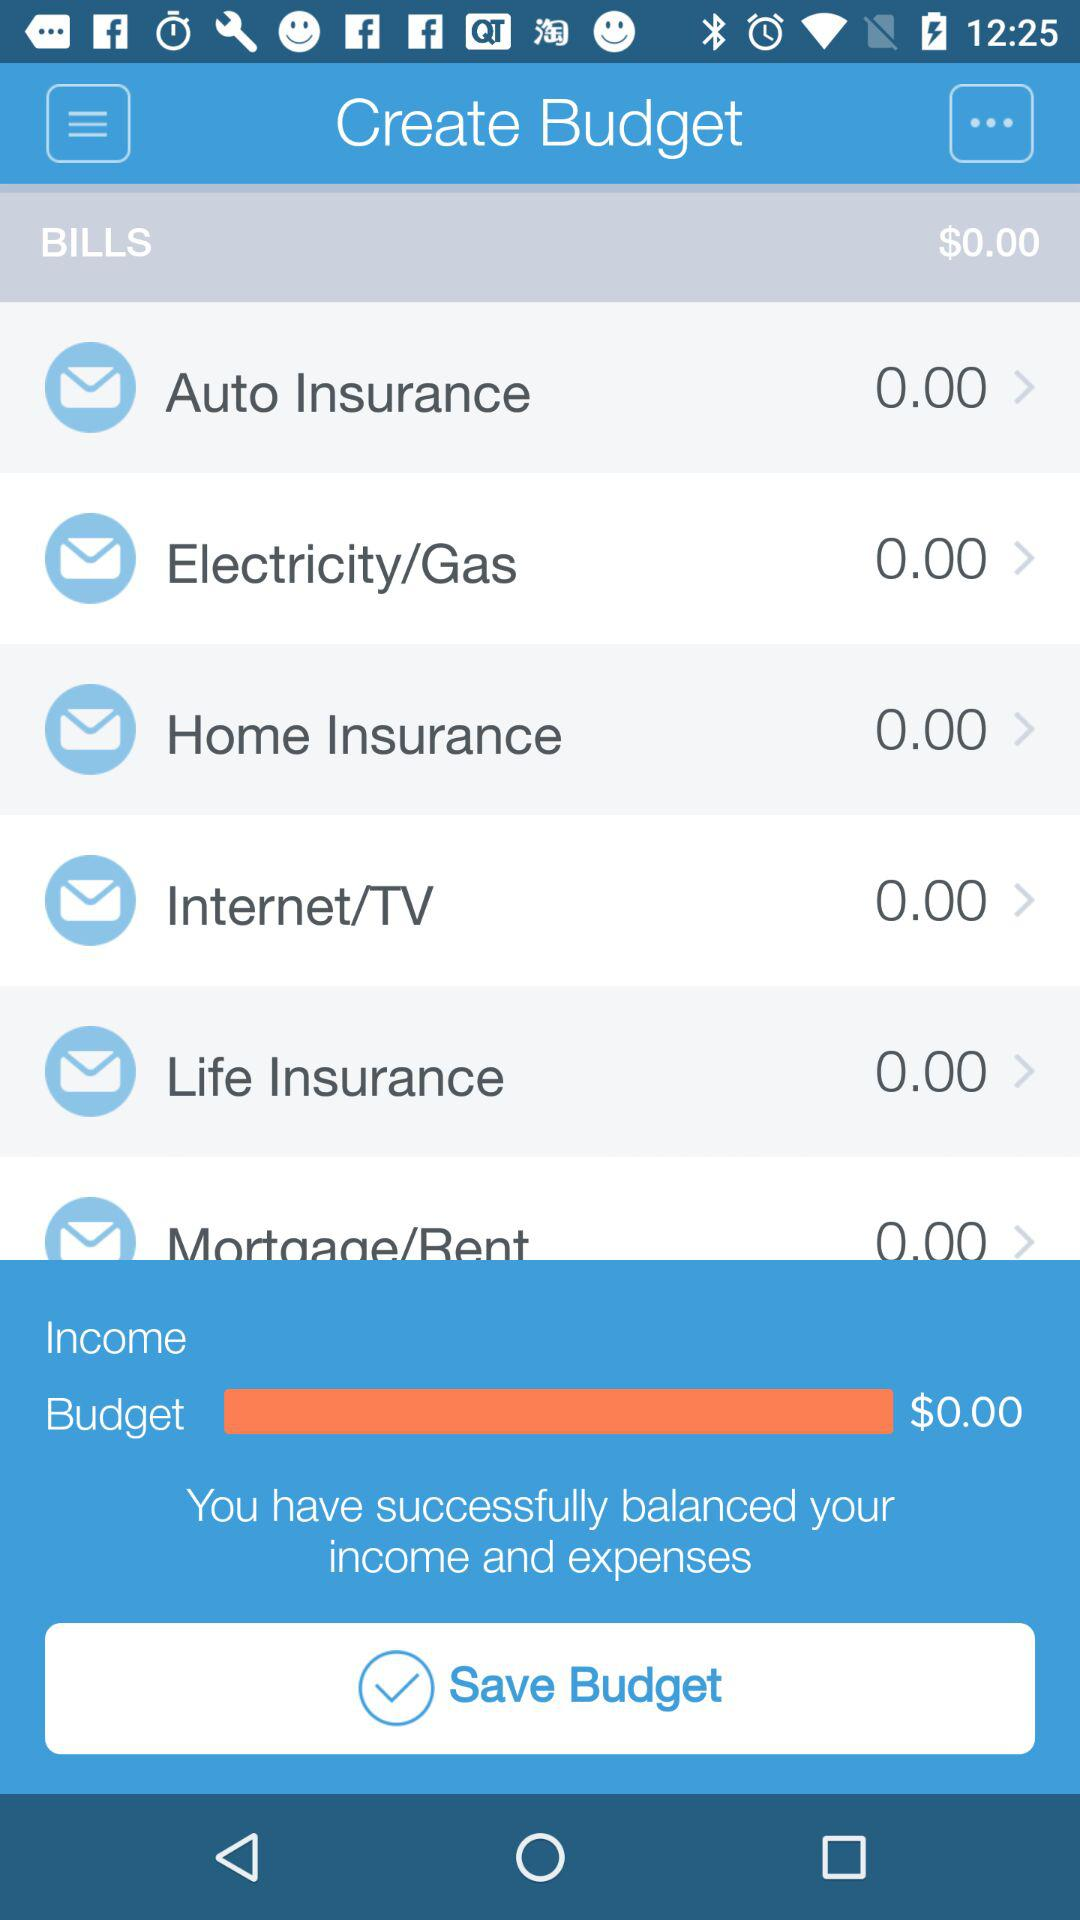How much do I need to pay in total for bills?
Answer the question using a single word or phrase. $0.00 